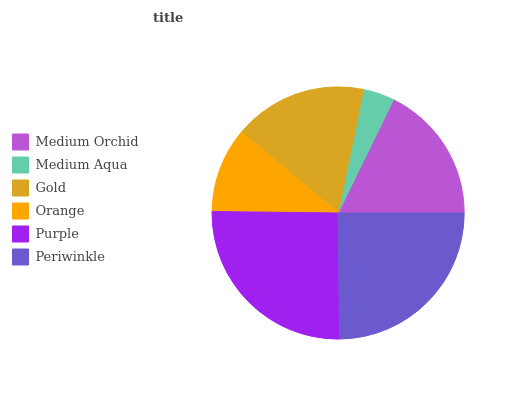Is Medium Aqua the minimum?
Answer yes or no. Yes. Is Purple the maximum?
Answer yes or no. Yes. Is Gold the minimum?
Answer yes or no. No. Is Gold the maximum?
Answer yes or no. No. Is Gold greater than Medium Aqua?
Answer yes or no. Yes. Is Medium Aqua less than Gold?
Answer yes or no. Yes. Is Medium Aqua greater than Gold?
Answer yes or no. No. Is Gold less than Medium Aqua?
Answer yes or no. No. Is Medium Orchid the high median?
Answer yes or no. Yes. Is Gold the low median?
Answer yes or no. Yes. Is Orange the high median?
Answer yes or no. No. Is Periwinkle the low median?
Answer yes or no. No. 